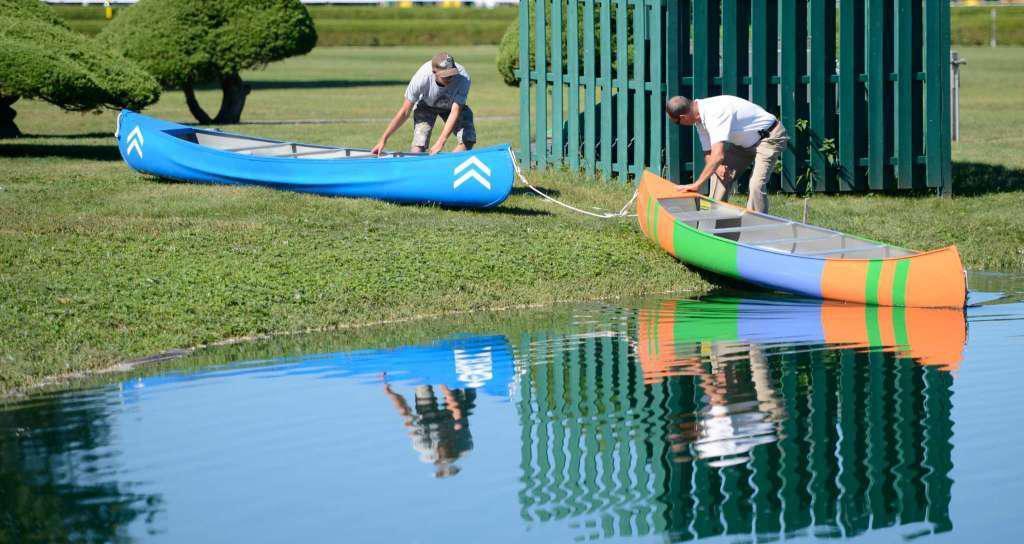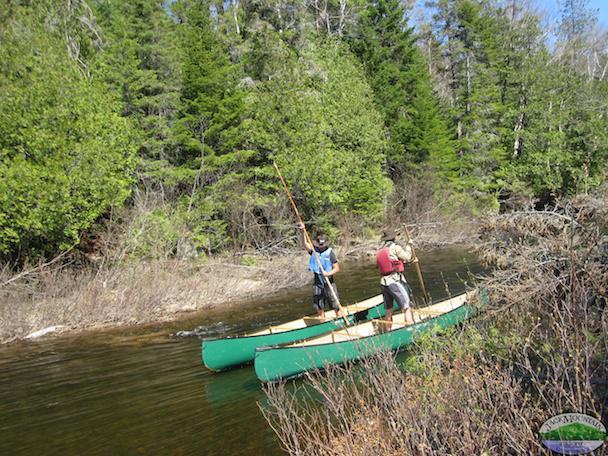The first image is the image on the left, the second image is the image on the right. Analyze the images presented: Is the assertion "Two canoes are upside down." valid? Answer yes or no. No. The first image is the image on the left, the second image is the image on the right. Analyze the images presented: Is the assertion "At least one boat has at least one person sitting in it." valid? Answer yes or no. No. 